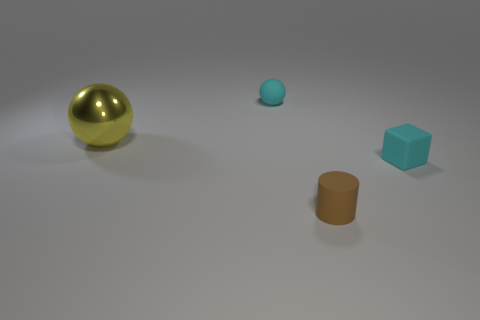Is the big ball made of the same material as the tiny cyan thing that is right of the tiny sphere?
Your response must be concise. No. Are any small things visible?
Ensure brevity in your answer.  Yes. Is there a tiny brown matte thing that is left of the cyan matte object that is on the left side of the brown rubber object on the left side of the tiny rubber block?
Give a very brief answer. No. What number of tiny things are either green cylinders or yellow things?
Your answer should be compact. 0. What color is the matte ball that is the same size as the matte cylinder?
Make the answer very short. Cyan. What number of shiny things are right of the small cyan rubber block?
Provide a short and direct response. 0. Is there another cube that has the same material as the tiny cyan block?
Provide a succinct answer. No. What is the shape of the tiny rubber object that is the same color as the tiny matte sphere?
Your answer should be very brief. Cube. The tiny thing on the right side of the small brown matte object is what color?
Your answer should be compact. Cyan. Are there an equal number of tiny cyan rubber cubes on the left side of the tiny matte cylinder and shiny things that are behind the small cyan sphere?
Your answer should be very brief. Yes. 